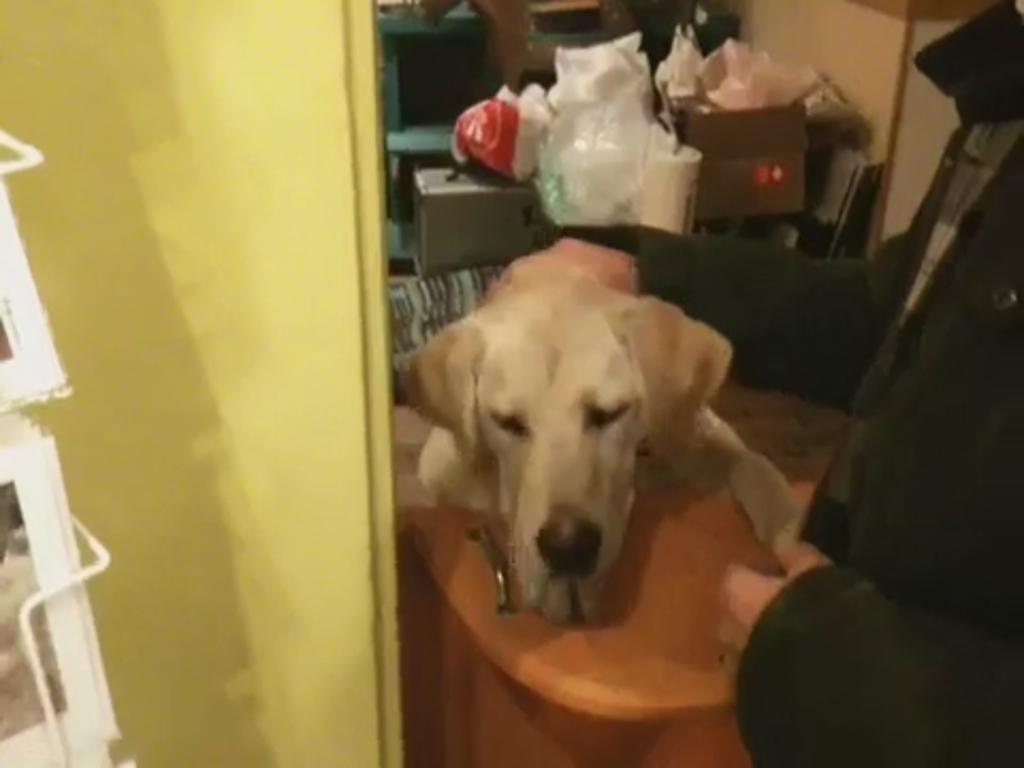Could you give a brief overview of what you see in this image? In this picture I can see a person holding a dog, there are cardboard boxes and some other objects. 